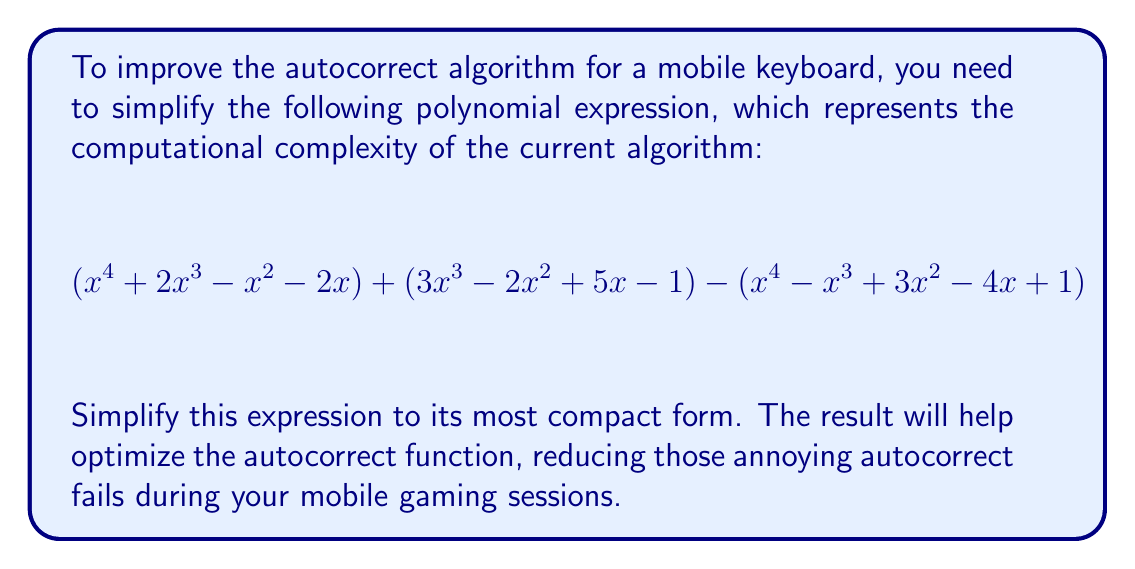What is the answer to this math problem? Let's simplify this polynomial expression step by step:

1) First, let's group the like terms:
   $$(x^4 + 2x^3 - x^2 - 2x) + (3x^3 - 2x^2 + 5x - 1) - (x^4 - x^3 + 3x^2 - 4x + 1)$$

2) Distribute the negative sign to the last parenthesis:
   $$(x^4 + 2x^3 - x^2 - 2x) + (3x^3 - 2x^2 + 5x - 1) + (-x^4 + x^3 - 3x^2 + 4x - 1)$$

3) Now, let's combine like terms:

   For $x^4$: $x^4 + (-x^4) = 0$
   
   For $x^3$: $2x^3 + 3x^3 + x^3 = 6x^3$
   
   For $x^2$: $-x^2 + (-2x^2) + (-3x^2) = -6x^2$
   
   For $x$: $-2x + 5x + 4x = 7x$
   
   For constants: $-1 + (-1) = -2$

4) Writing our simplified polynomial:
   $$6x^3 - 6x^2 + 7x - 2$$

This simplified form represents the optimized computational complexity of the autocorrect algorithm.
Answer: $6x^3 - 6x^2 + 7x - 2$ 